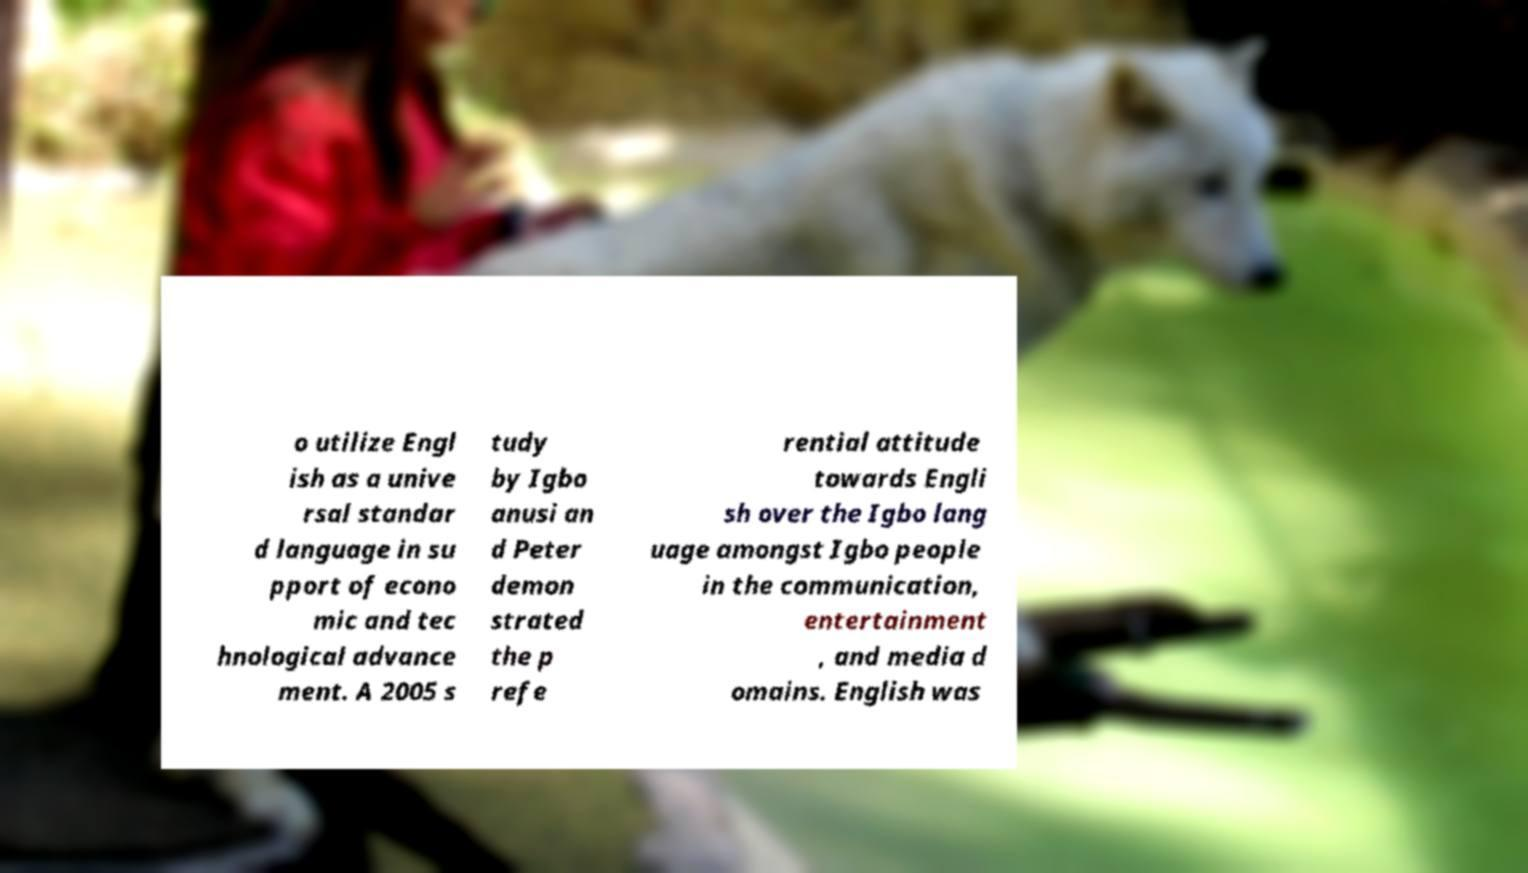Please read and relay the text visible in this image. What does it say? o utilize Engl ish as a unive rsal standar d language in su pport of econo mic and tec hnological advance ment. A 2005 s tudy by Igbo anusi an d Peter demon strated the p refe rential attitude towards Engli sh over the Igbo lang uage amongst Igbo people in the communication, entertainment , and media d omains. English was 